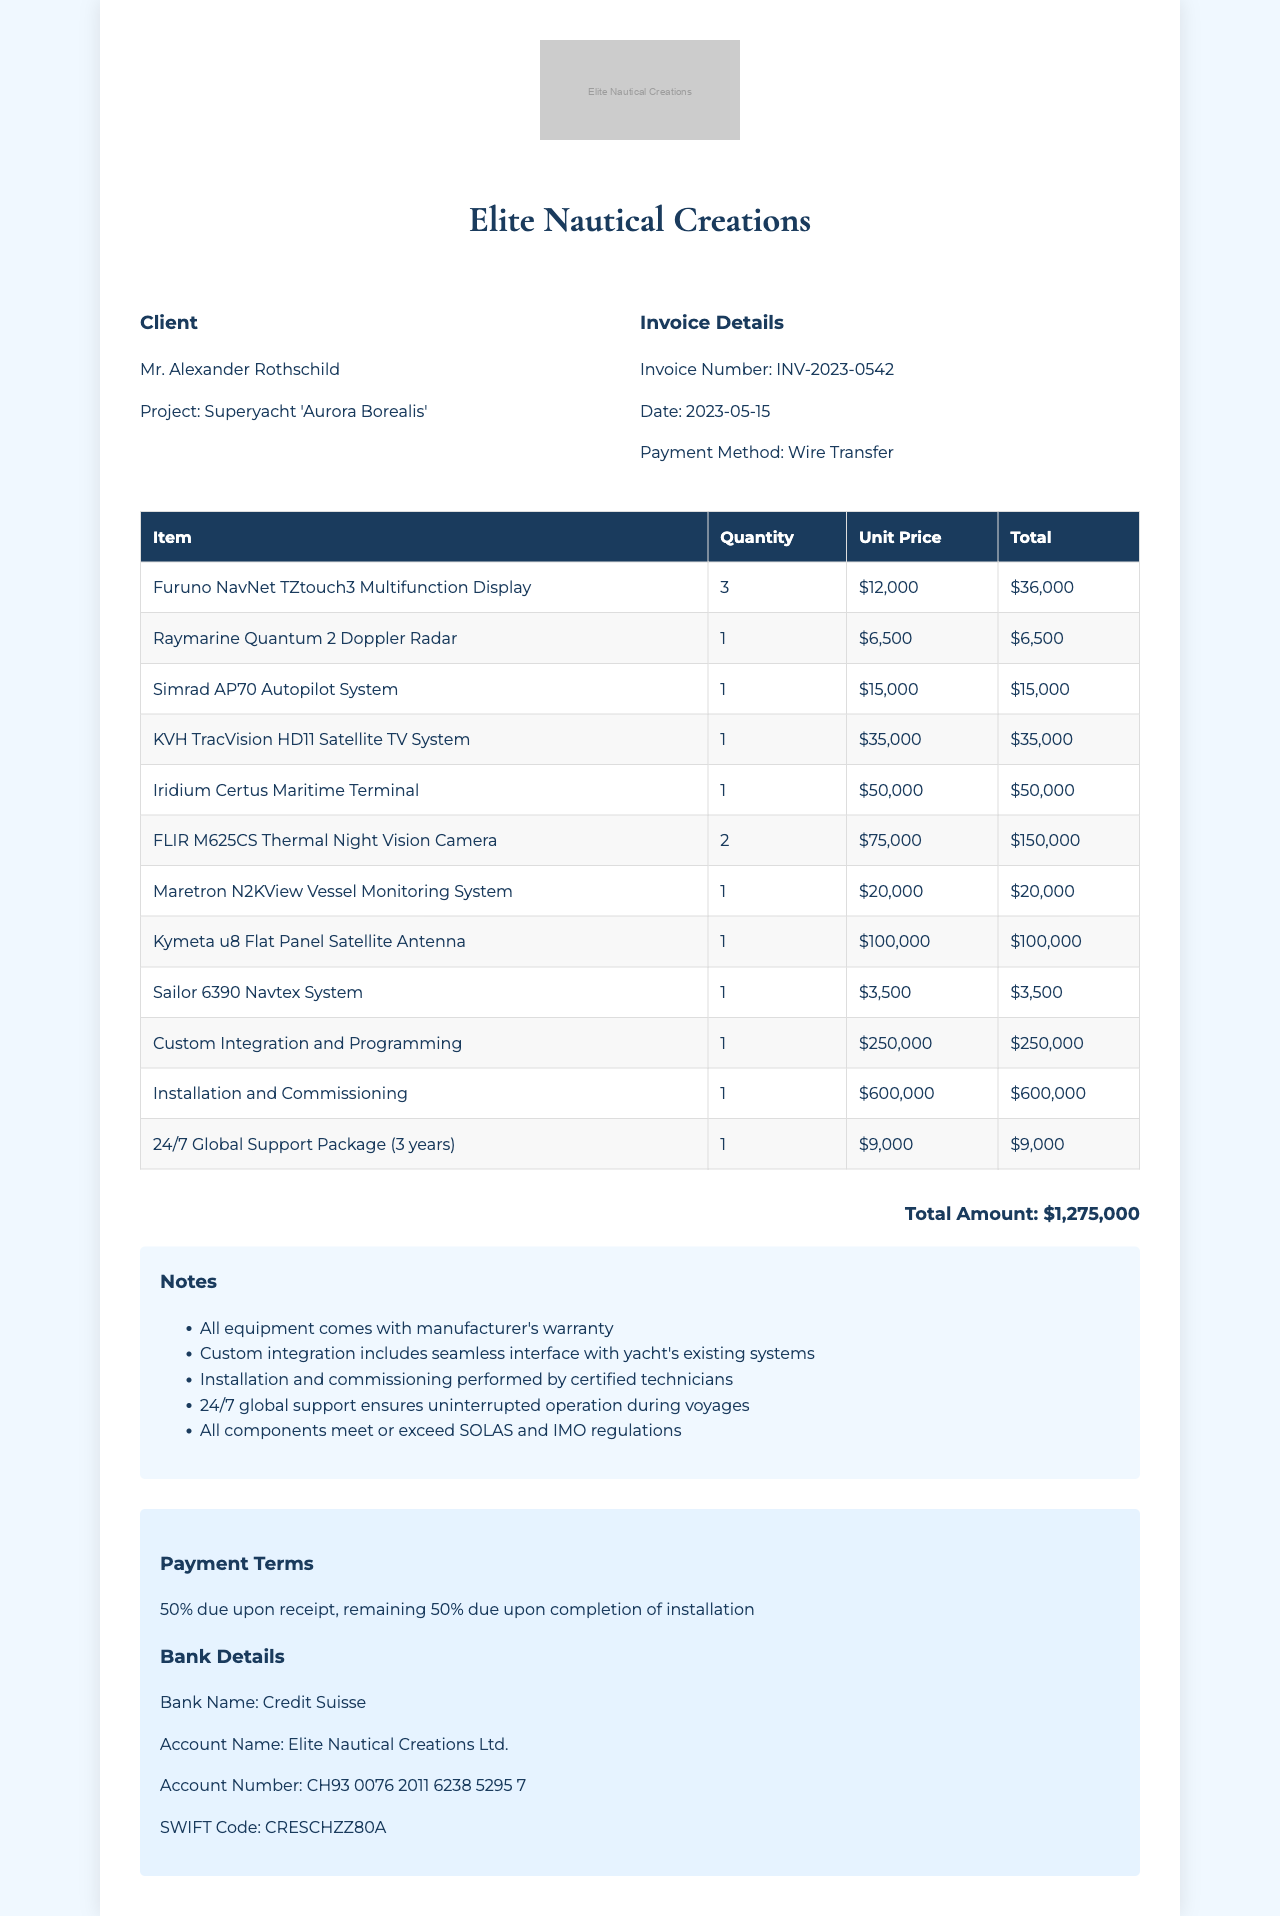What is the invoice number? The invoice number is specifically listed in the document as a unique identifier for the transaction.
Answer: INV-2023-0542 Who is the client? The client's name is clearly indicated in the document as the individual associated with the purchase.
Answer: Mr. Alexander Rothschild What is the total amount? The total amount denotes the full cost of the installation project and is provided explicitly in the document.
Answer: $1,275,000 What is the payment method? The method of payment used for the transaction is mentioned in the document, indicating how the payment was made.
Answer: Wire Transfer How many Furuno NavNet TZtouch3 Multifunction Displays were ordered? The quantity of a specific item ordered is detailed in the itemized list, showing how many of that item were purchased.
Answer: 3 What component had the highest unit price? The component with the highest unit price can be determined by comparing the individual unit prices listed for each item.
Answer: FLIR M625CS Thermal Night Vision Camera What is the duration of the Global Support Package? The duration for the support package is mentioned, which specifies how long the support will be available.
Answer: 3 years What is stated about the installation? A note in the document clarifies the qualifications involved in carrying out the installation of systems.
Answer: Certified technicians What is included in the payment terms? The payment terms outline the conditions and timeline for payments associated with the project.
Answer: 50% due upon receipt, remaining 50% due upon completion of installation 